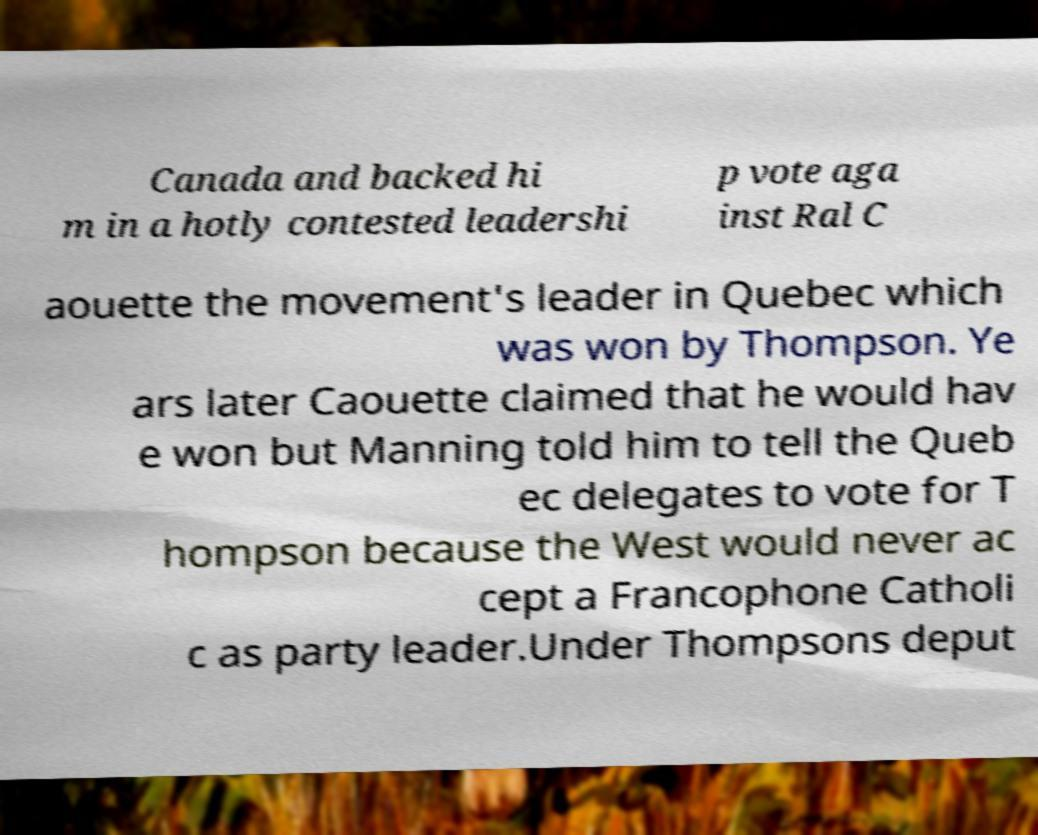Please identify and transcribe the text found in this image. Canada and backed hi m in a hotly contested leadershi p vote aga inst Ral C aouette the movement's leader in Quebec which was won by Thompson. Ye ars later Caouette claimed that he would hav e won but Manning told him to tell the Queb ec delegates to vote for T hompson because the West would never ac cept a Francophone Catholi c as party leader.Under Thompsons deput 